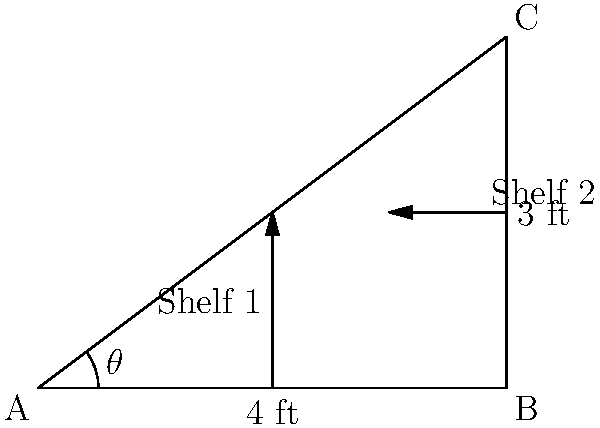In your retail shop, two shelves meet at a corner forming a right angle. Shelf 1 is 4 feet long, and Shelf 2 is 3 feet long. What is the angle $\theta$ between the diagonal line connecting the ends of the shelves and Shelf 1? To solve this problem, we can use trigonometry in the right triangle formed by the shelves and the diagonal line.

1) First, we recognize that the shelves form a right triangle, with Shelf 1 as the base (4 ft) and Shelf 2 as the height (3 ft).

2) The diagonal line forms the hypotenuse of this right triangle.

3) We want to find the angle $\theta$ between the hypotenuse and Shelf 1 (the base).

4) In a right triangle, we can use the tangent function to find this angle:

   $\tan(\theta) = \frac{\text{opposite}}{\text{adjacent}} = \frac{\text{height}}{\text{base}} = \frac{3}{4}$

5) To find $\theta$, we need to use the inverse tangent (arctangent) function:

   $\theta = \arctan(\frac{3}{4})$

6) Using a calculator or trigonometric tables, we can determine that:

   $\theta \approx 36.87°$

Therefore, the angle between the diagonal line and Shelf 1 is approximately 36.87 degrees.
Answer: $\arctan(\frac{3}{4}) \approx 36.87°$ 